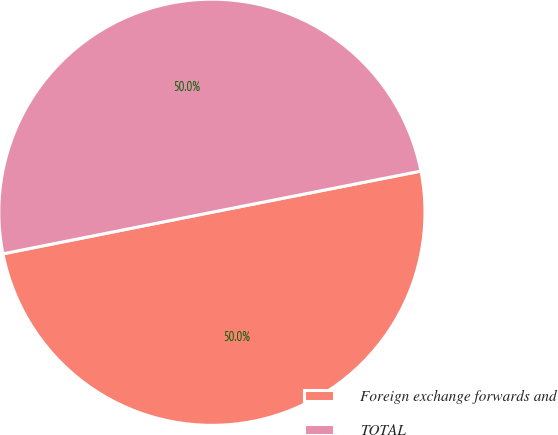Convert chart to OTSL. <chart><loc_0><loc_0><loc_500><loc_500><pie_chart><fcel>Foreign exchange forwards and<fcel>TOTAL<nl><fcel>49.97%<fcel>50.03%<nl></chart> 